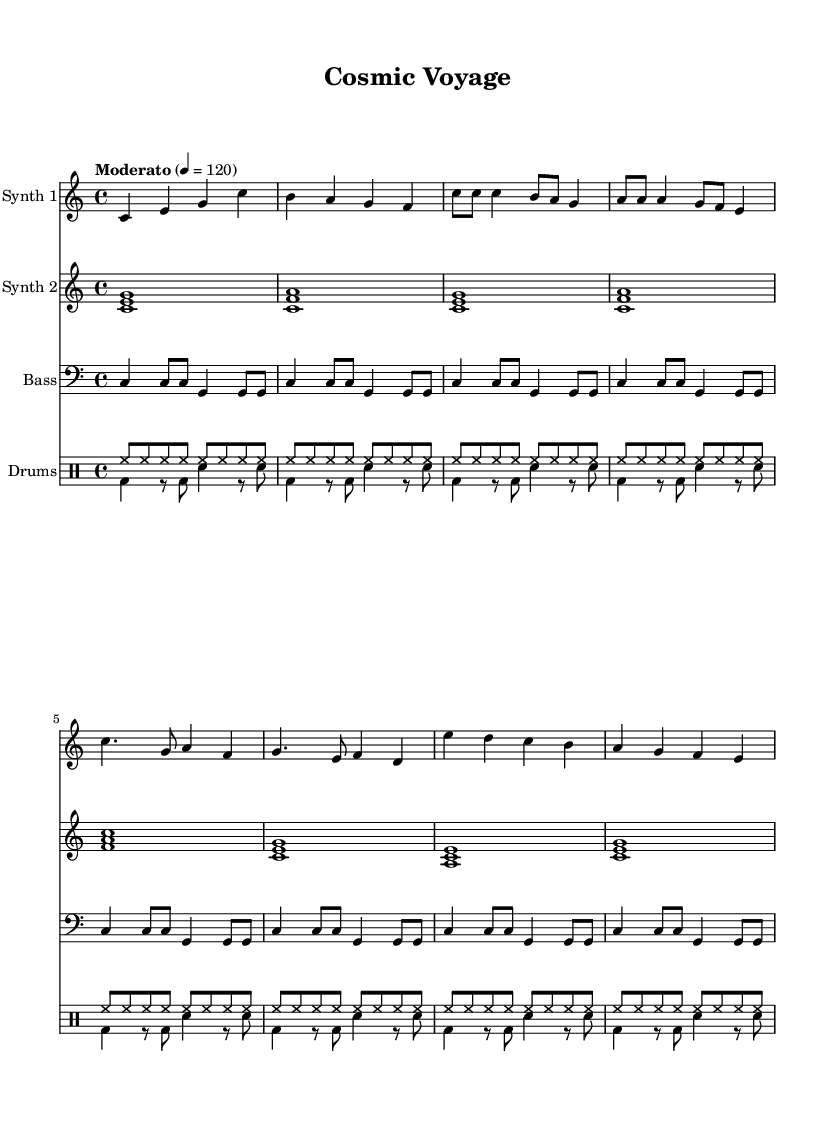What is the key signature of this music? The key signature is C major, indicated by the absence of sharps or flats in the left-hand corner of the staff at the beginning of the sheet music.
Answer: C major What is the time signature of this music? The time signature is 4/4, which is noted at the beginning of the score. This means there are four beats per measure and the quarter note gets one beat.
Answer: 4/4 What is the tempo marking for this piece? The tempo marking is "Moderato," which suggests a moderate tempo, and the BPM is set at 120 beats per minute as indicated next to the tempo marking.
Answer: Moderato How many measures are in the chorus section? The chorus section consists of two measures, identifiable from the music where chords alternate in a straightforward pattern compared to other sections like the intro or verse.
Answer: 2 What type of synthesizer is represented by the first staff? The first staff is labeled "Synth 1," indicating it represents a synthesized sound, specifically the main melodic line of the composition.
Answer: Synth 1 How does the drum pattern in the first voice differ from the second? The first voice features a hi-hat pattern with continuous eighth notes, while the second voice includes a combination of bass drum and snare rhythms, creating a contrasting texture.
Answer: Continuous and contrasting 